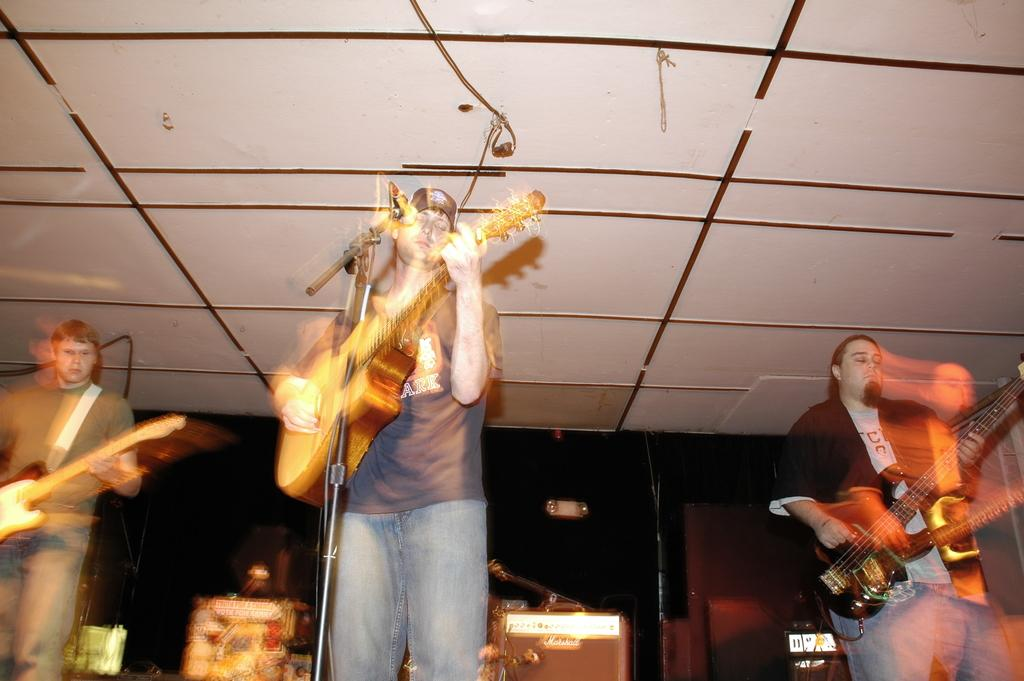How many people are in the image? There are three people in the image. What are the people doing in the image? The people are playing guitars, and one person is singing into a microphone. What can be seen in the background of the image? There are boxes and a wall in the background of the image. How would you describe the quality of the image? The image is blurry. What type of bottle is being used by the fireman in the image? There is no fireman or bottle present in the image. How many crows are perched on the wall in the image? There are no crows present in the image; only the people, guitars, microphone, boxes, and wall can be seen. 